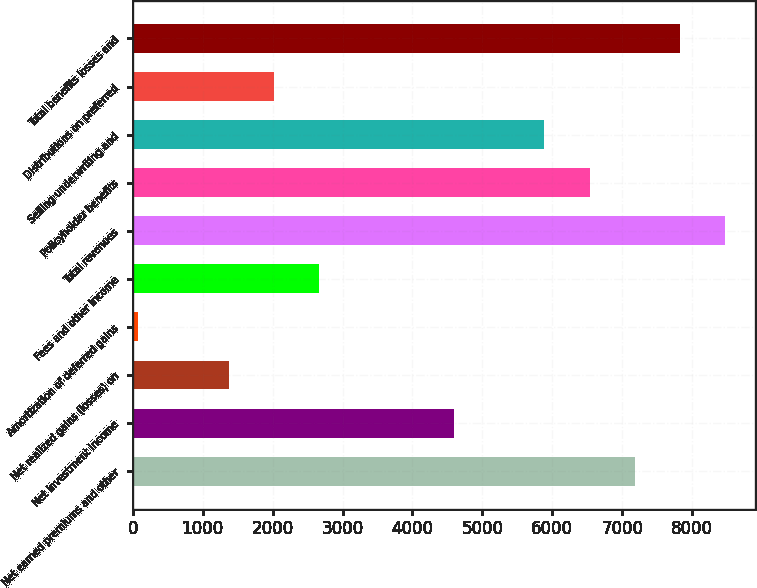<chart> <loc_0><loc_0><loc_500><loc_500><bar_chart><fcel>Net earned premiums and other<fcel>Net investment income<fcel>Net realized gains (losses) on<fcel>Amortization of deferred gains<fcel>Fees and other income<fcel>Total revenues<fcel>Policyholder benefits<fcel>Selling underwriting and<fcel>Distributions on preferred<fcel>Total benefits losses and<nl><fcel>7177.2<fcel>4596.4<fcel>1370.4<fcel>80<fcel>2660.8<fcel>8467.6<fcel>6532<fcel>5886.8<fcel>2015.6<fcel>7822.4<nl></chart> 